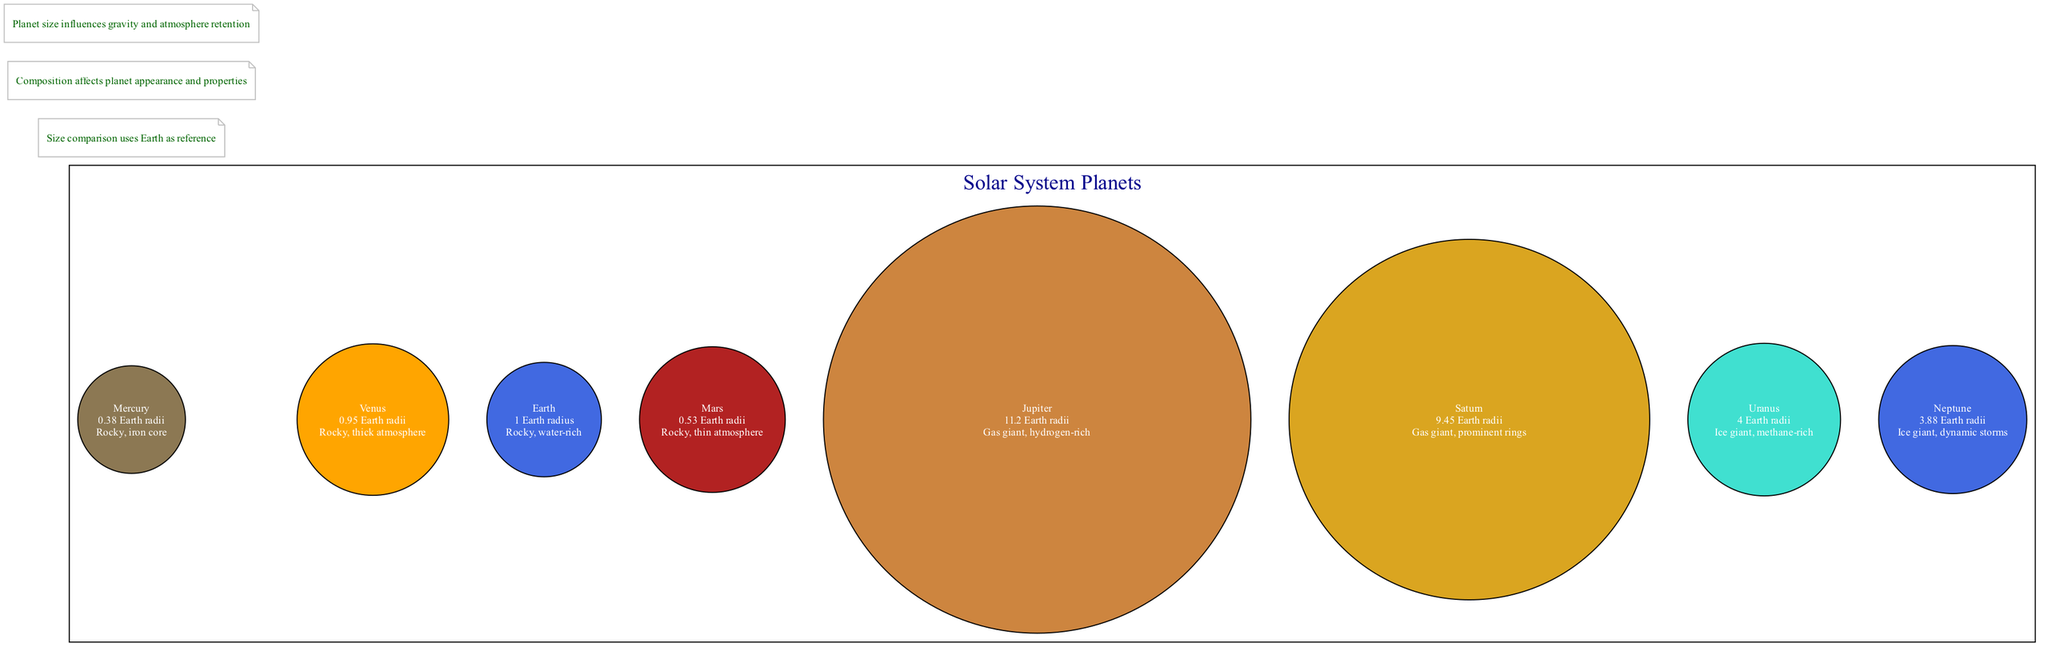What is the size of Jupiter in relation to Earth? The diagram states that Jupiter has a size of 11.2 Earth radii, which indicates that it is significantly larger than Earth.
Answer: 11.2 Earth radii Which planet has the smallest size? By looking at the sizes displayed in the diagram, Mercury is listed with a size of 0.38 Earth radii, making it the smallest planet shown.
Answer: Mercury What type of planet is Uranus? The diagram notes that Uranus is classified as an ice giant and is methane-rich, indicating its composition type.
Answer: Ice giant How many gas giants are represented in the diagram? The diagram contains Saturn and Jupiter as gas giants, making it necessary to count these two planets to determine the total number of gas giants, which is two.
Answer: 2 Which planet has a rocky, thin atmosphere? Referring to the details provided in the diagram, Mars is described as having a rocky composition with a thin atmosphere.
Answer: Mars What is the composition of Venus? The diagram shows that Venus is composed of rock and has a thick atmosphere, providing specific details about its chemical and physical makeup.
Answer: Rocky, thick atmosphere Which is larger, Neptune or Uranus? The diagram provides Neptune's size as 3.88 Earth radii and Uranus's size as 4 Earth radii, so by comparing these two sizes, it is clear that Uranus is larger.
Answer: Uranus What visual note indicates about planetary size? The notes in the diagram inform that "Planet size influences gravity and atmosphere retention," emphasizing the importance of size in relation to planetary characteristics.
Answer: Size influences gravity and atmosphere retention 